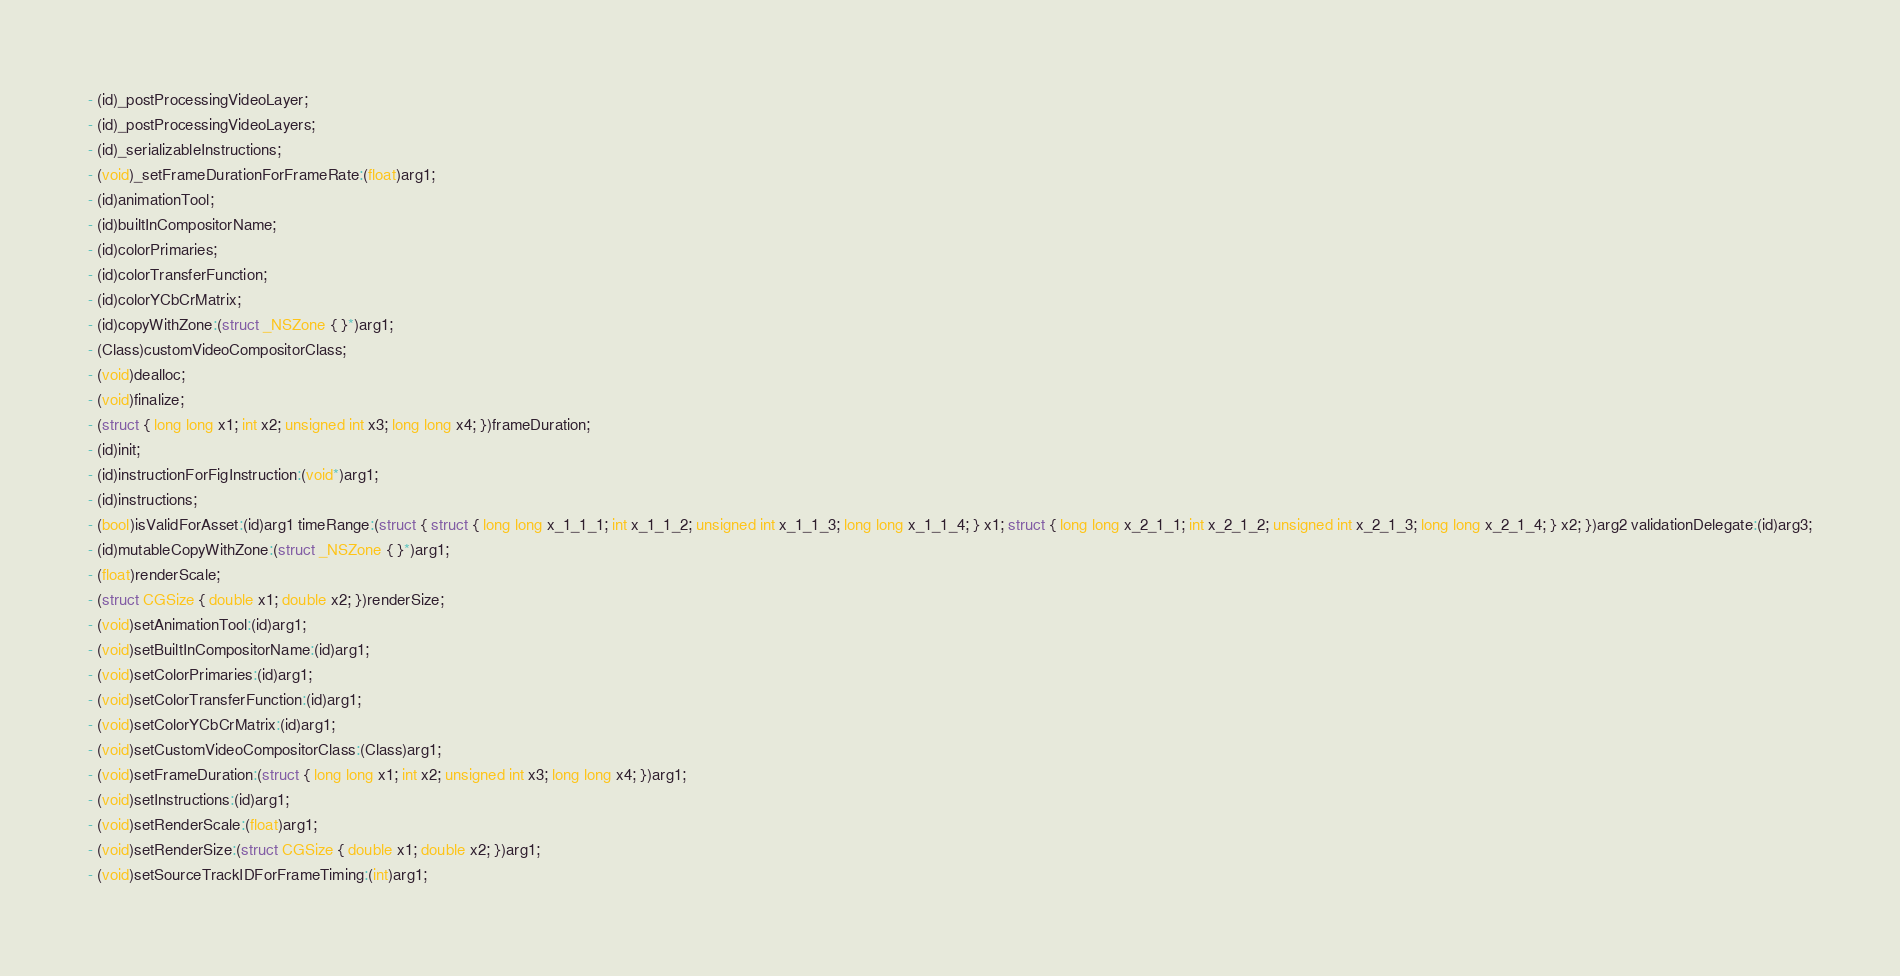<code> <loc_0><loc_0><loc_500><loc_500><_C_>- (id)_postProcessingVideoLayer;
- (id)_postProcessingVideoLayers;
- (id)_serializableInstructions;
- (void)_setFrameDurationForFrameRate:(float)arg1;
- (id)animationTool;
- (id)builtInCompositorName;
- (id)colorPrimaries;
- (id)colorTransferFunction;
- (id)colorYCbCrMatrix;
- (id)copyWithZone:(struct _NSZone { }*)arg1;
- (Class)customVideoCompositorClass;
- (void)dealloc;
- (void)finalize;
- (struct { long long x1; int x2; unsigned int x3; long long x4; })frameDuration;
- (id)init;
- (id)instructionForFigInstruction:(void*)arg1;
- (id)instructions;
- (bool)isValidForAsset:(id)arg1 timeRange:(struct { struct { long long x_1_1_1; int x_1_1_2; unsigned int x_1_1_3; long long x_1_1_4; } x1; struct { long long x_2_1_1; int x_2_1_2; unsigned int x_2_1_3; long long x_2_1_4; } x2; })arg2 validationDelegate:(id)arg3;
- (id)mutableCopyWithZone:(struct _NSZone { }*)arg1;
- (float)renderScale;
- (struct CGSize { double x1; double x2; })renderSize;
- (void)setAnimationTool:(id)arg1;
- (void)setBuiltInCompositorName:(id)arg1;
- (void)setColorPrimaries:(id)arg1;
- (void)setColorTransferFunction:(id)arg1;
- (void)setColorYCbCrMatrix:(id)arg1;
- (void)setCustomVideoCompositorClass:(Class)arg1;
- (void)setFrameDuration:(struct { long long x1; int x2; unsigned int x3; long long x4; })arg1;
- (void)setInstructions:(id)arg1;
- (void)setRenderScale:(float)arg1;
- (void)setRenderSize:(struct CGSize { double x1; double x2; })arg1;
- (void)setSourceTrackIDForFrameTiming:(int)arg1;</code> 